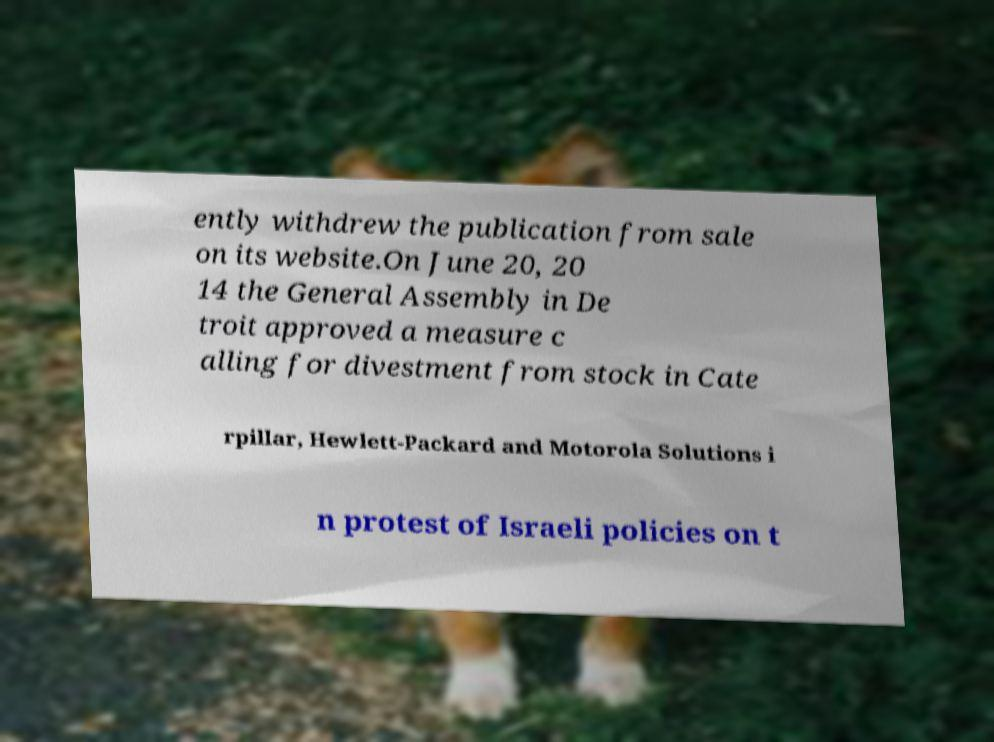Could you assist in decoding the text presented in this image and type it out clearly? ently withdrew the publication from sale on its website.On June 20, 20 14 the General Assembly in De troit approved a measure c alling for divestment from stock in Cate rpillar, Hewlett-Packard and Motorola Solutions i n protest of Israeli policies on t 